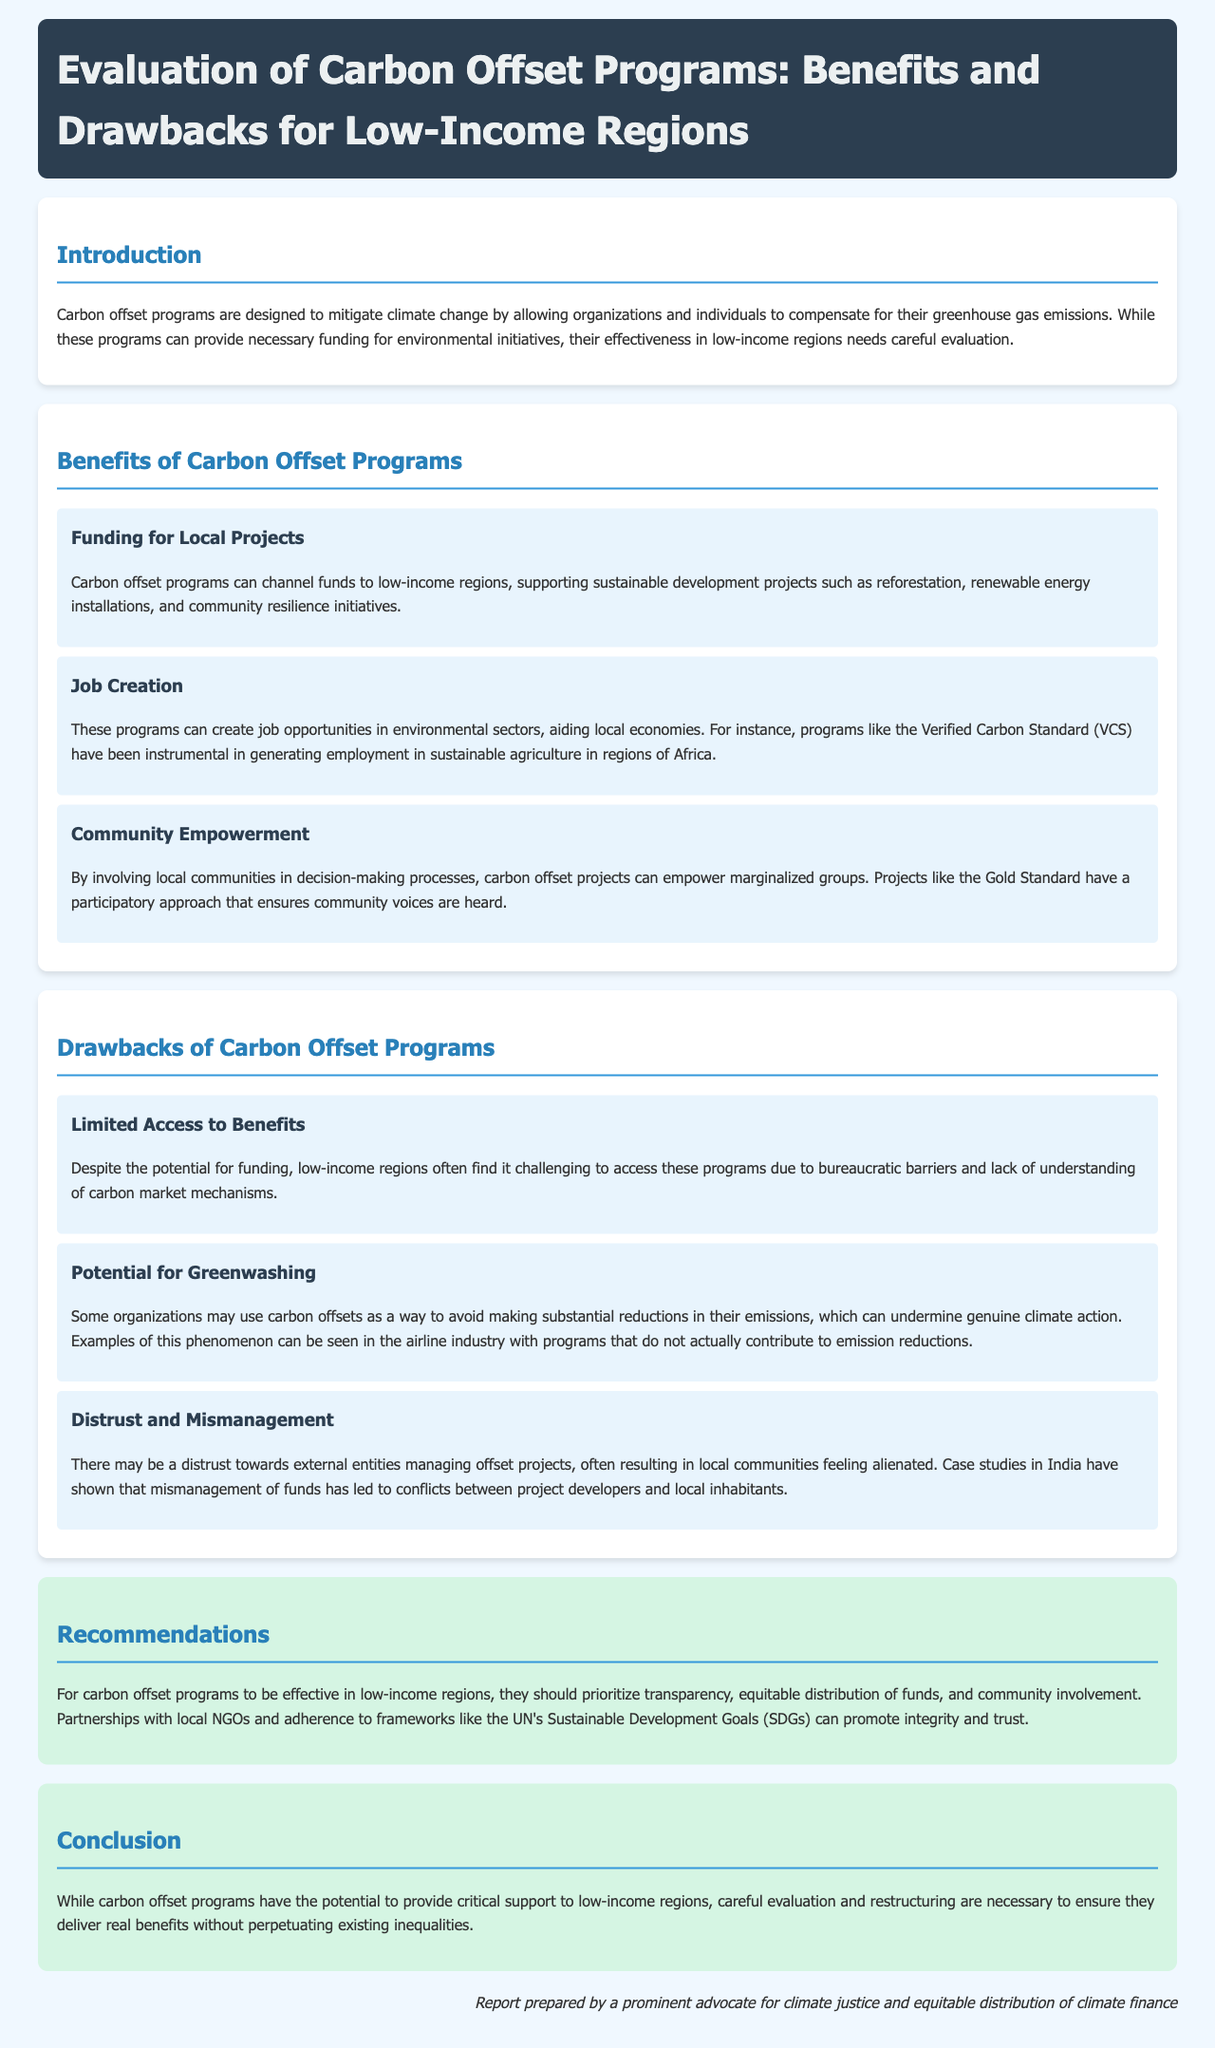what are the benefits of carbon offset programs? The document lists three main benefits: funding for local projects, job creation, and community empowerment.
Answer: funding for local projects, job creation, community empowerment what is one drawback of carbon offset programs? The document identifies three drawbacks, including limited access to benefits, potential for greenwashing, and distrust and mismanagement.
Answer: limited access to benefits which region is mentioned as benefiting from sustainable agriculture job creation? The document specifically mentions regions of Africa in relation to job creation from programs like the Verified Carbon Standard.
Answer: Africa what is the recommendation for carbon offset programs? The report recommends prioritizing transparency, equitable distribution of funds, and community involvement for effectiveness in low-income regions.
Answer: transparency, equitable distribution of funds, community involvement who prepared the report? The report states it was prepared by a prominent advocate for climate justice and equitable distribution of climate finance.
Answer: a prominent advocate for climate justice and equitable distribution of climate finance what approach does the Gold Standard adopt? The report mentions that the Gold Standard has a participatory approach that ensures community voices are heard.
Answer: participatory approach how does the document classify its sections? The document is organized into sections such as introduction, benefits, drawbacks, recommendations, and conclusion.
Answer: introduction, benefits, drawbacks, recommendations, conclusion what are the two types of barriers faced by low-income regions regarding carbon offset programs? The report mentions bureaucratic barriers and lack of understanding of carbon market mechanisms as challenges.
Answer: bureaucratic barriers, lack of understanding what is highlighted as a potential misuse of carbon offsets? The document describes greenwashing as a potential misuse, where organizations avoid making significant emission reductions.
Answer: greenwashing 